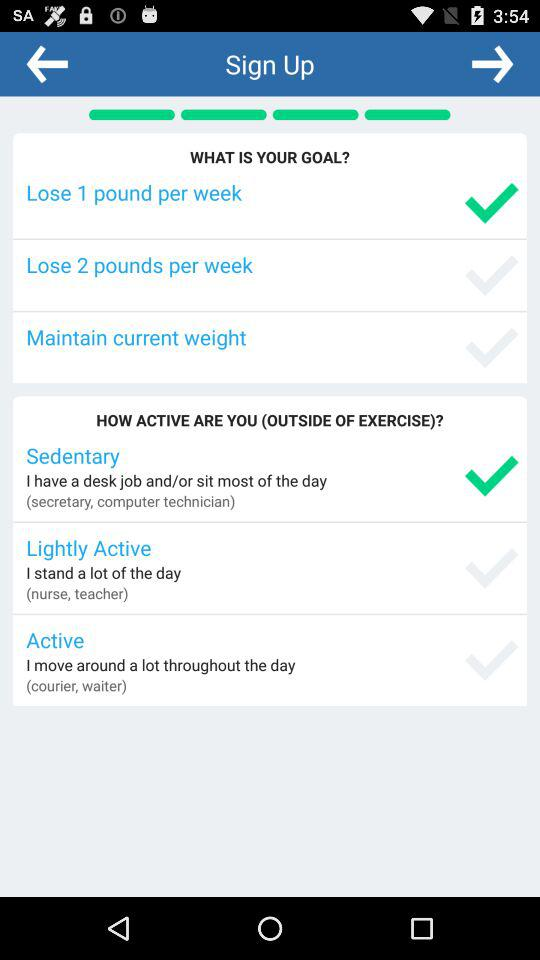How many weight loss goals are available?
Answer the question using a single word or phrase. 3 